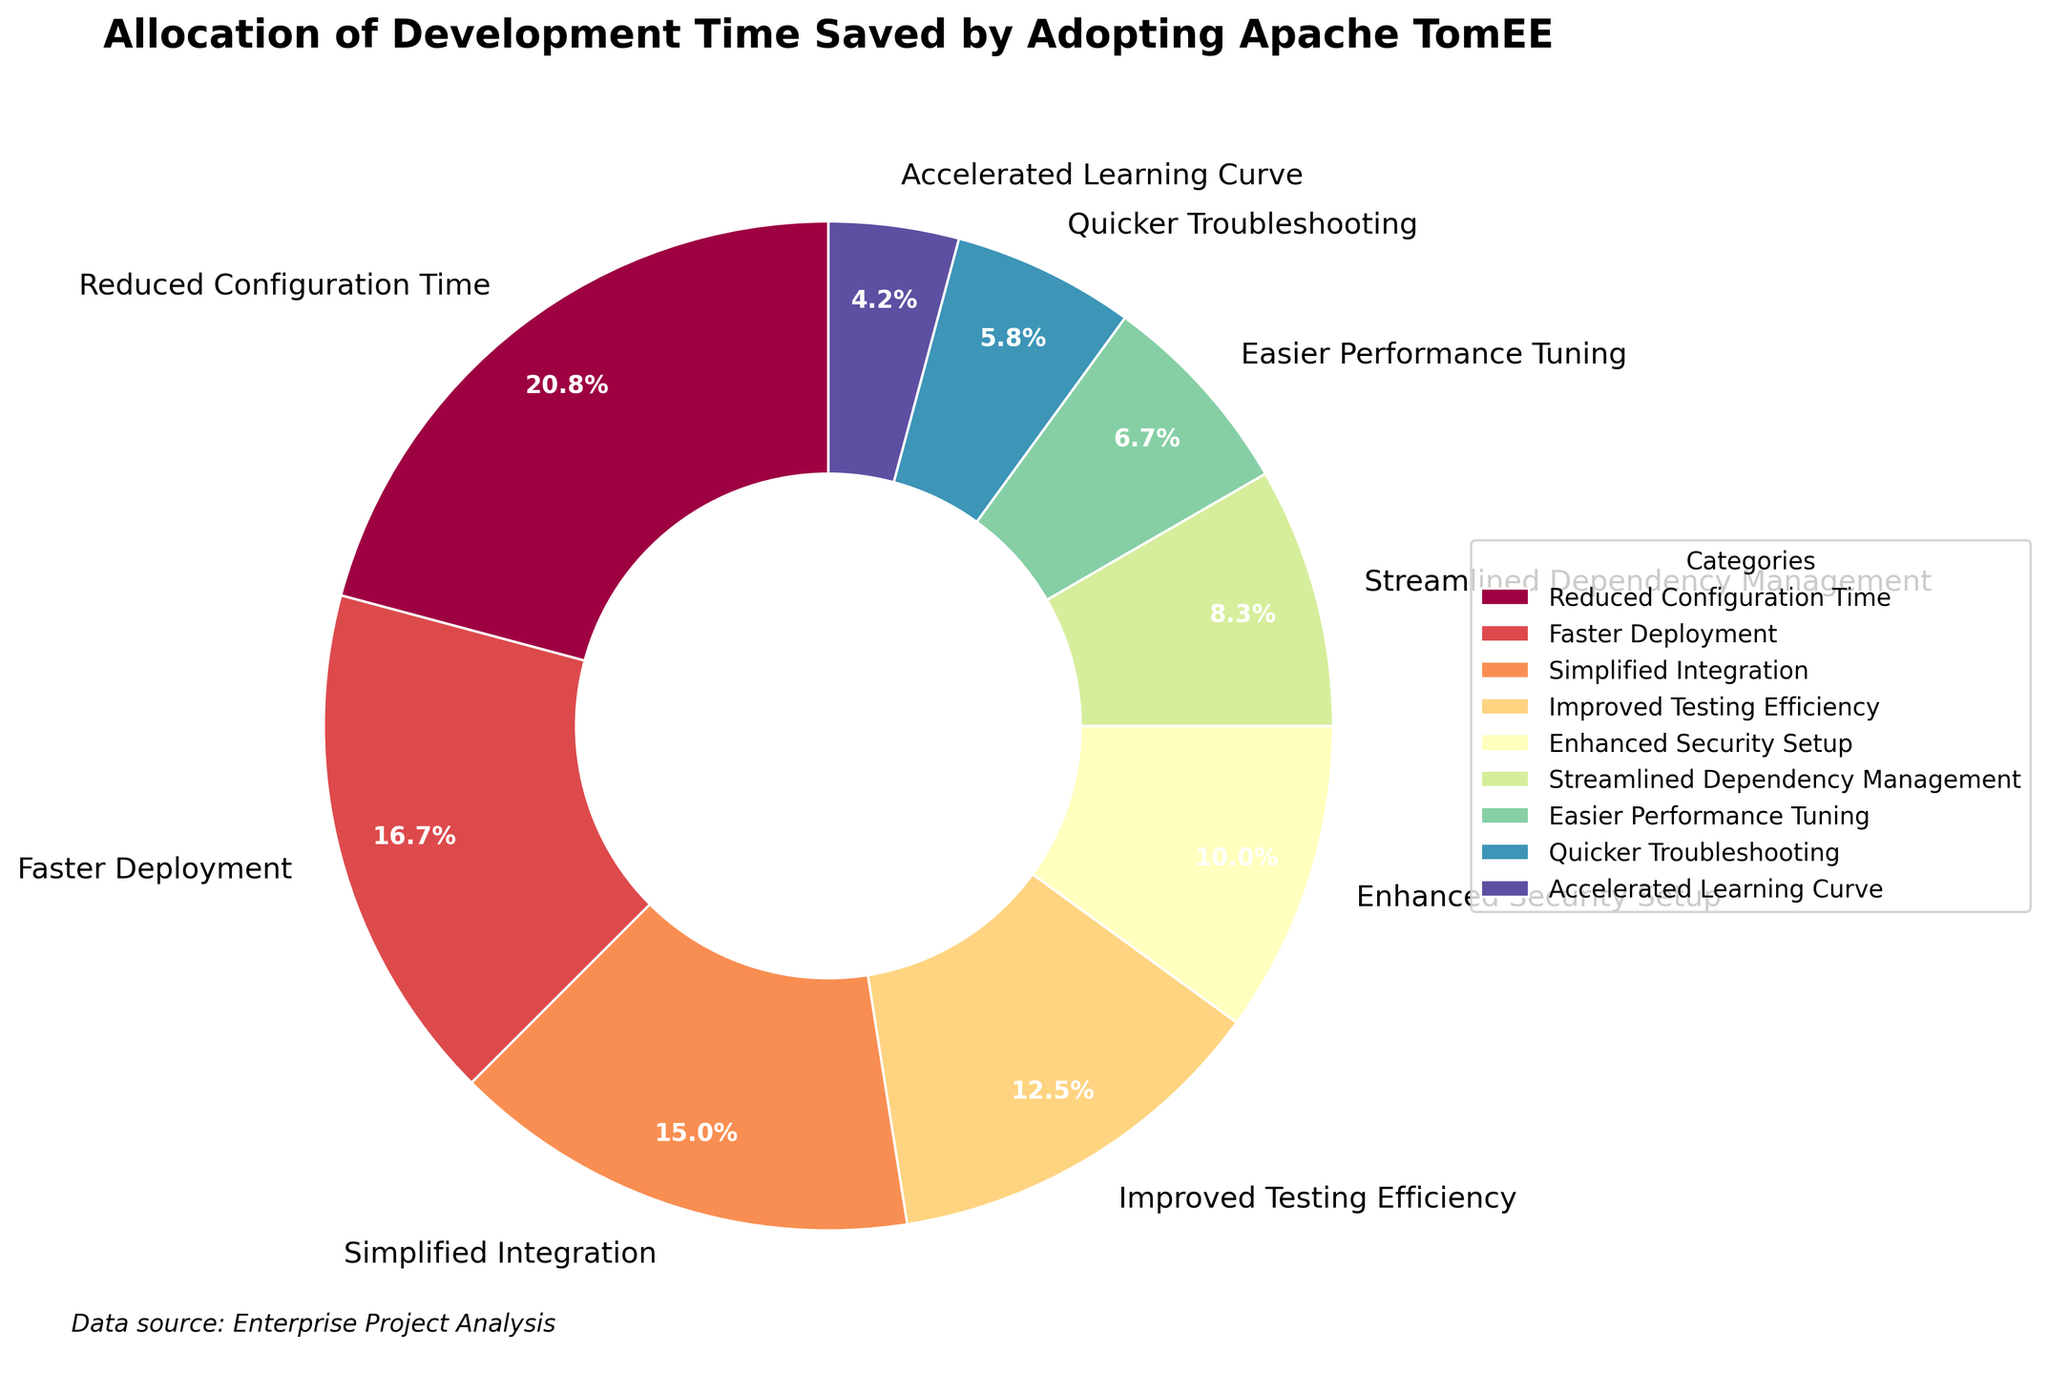Which category has the highest allocation of development time saved? The category with the highest percentage will have the highest allocation. Referring to the figure, "Reduced Configuration Time" has the highest allocation of 25%.
Answer: Reduced Configuration Time How much more development time is saved by "Reduced Configuration Time" compared to "Quicker Troubleshooting"? We need to subtract the percentage of "Quicker Troubleshooting" from "Reduced Configuration Time". That's 25% - 7% = 18%.
Answer: 18% Which categories altogether contribute to more than 50% of the development time saved? By summing the highest percentages until surpassing 50%, "Reduced Configuration Time" (25%), "Faster Deployment" (20%), and "Simplified Integration" (18%) together contribute 25% + 20% + 18% = 63%.
Answer: Reduced Configuration Time, Faster Deployment, Simplified Integration What is the difference in percentage between "Easier Performance Tuning" and "Enhanced Security Setup"? Subtract the percentage of "Easier Performance Tuning" from "Enhanced Security Setup". So, 12% - 8% = 4%.
Answer: 4% Which two categories have the closest allocation percentages? Comparing all percentages, "Simplified Integration" (18%) and "Improved Testing Efficiency" (15%) are the closest, with a difference of just 3%.
Answer: Simplified Integration, Improved Testing Efficiency What is the combined percentage for "Streamlined Dependency Management" and "Easier Performance Tuning"? Adding the percentages of "Streamlined Dependency Management" and "Easier Performance Tuning" gives 10% + 8% = 18%.
Answer: 18% Is there any category with an allocation of development time saved that is less than 10%? Referring to the figure, "Easier Performance Tuning" (8%), "Quicker Troubleshooting" (7%), and "Accelerated Learning Curve" (5%) all have allocations less than 10%.
Answer: Yes What is the total percentage for the bottom three categories in terms of development time saved? Summing the percentages of "Quicker Troubleshooting" (7%), "Accelerated Learning Curve" (5%), and "Easier Performance Tuning" (8%) results in 7% + 5% + 8% = 20%.
Answer: 20% 